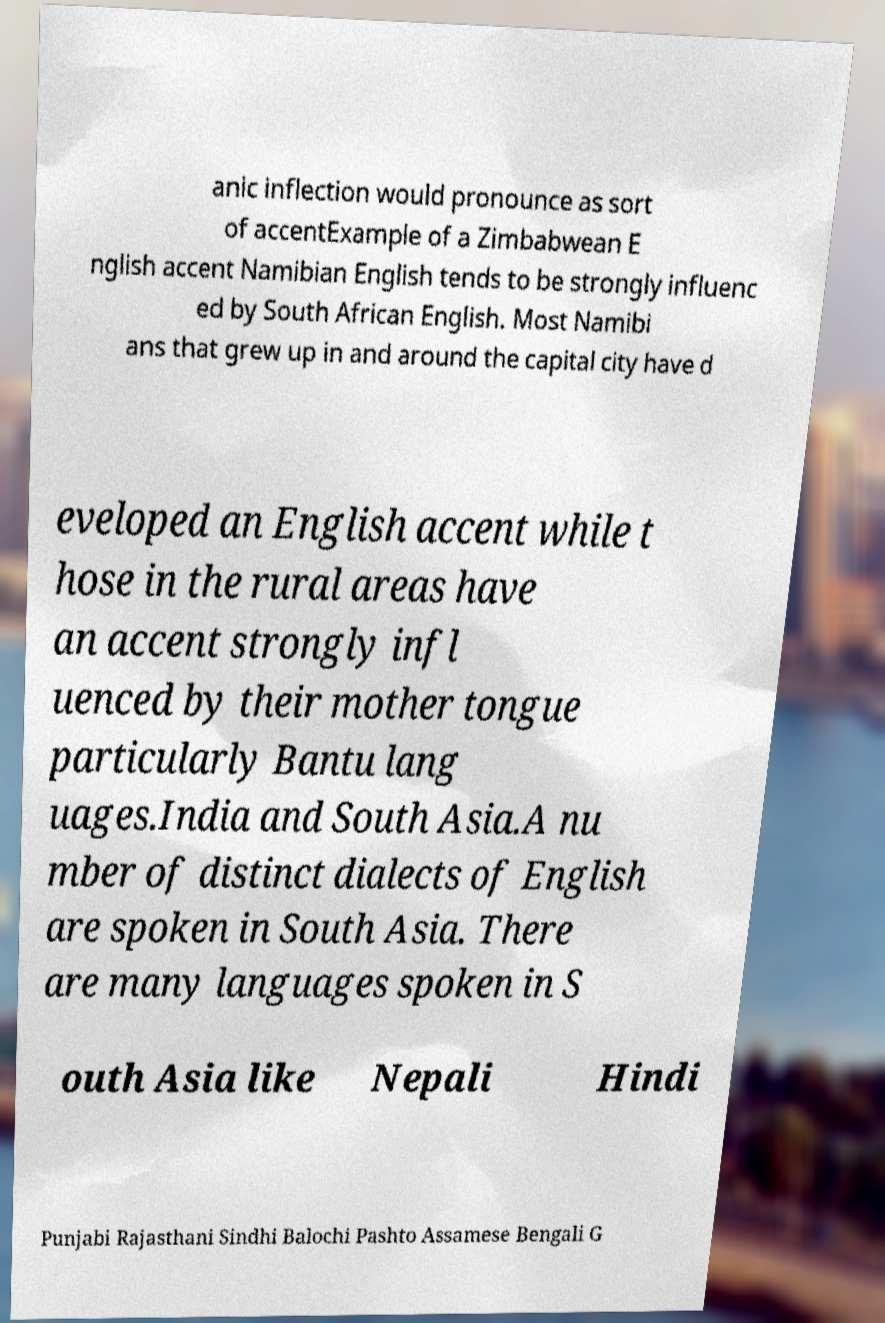I need the written content from this picture converted into text. Can you do that? anic inflection would pronounce as sort of accentExample of a Zimbabwean E nglish accent Namibian English tends to be strongly influenc ed by South African English. Most Namibi ans that grew up in and around the capital city have d eveloped an English accent while t hose in the rural areas have an accent strongly infl uenced by their mother tongue particularly Bantu lang uages.India and South Asia.A nu mber of distinct dialects of English are spoken in South Asia. There are many languages spoken in S outh Asia like Nepali Hindi Punjabi Rajasthani Sindhi Balochi Pashto Assamese Bengali G 